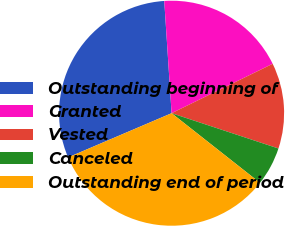Convert chart. <chart><loc_0><loc_0><loc_500><loc_500><pie_chart><fcel>Outstanding beginning of<fcel>Granted<fcel>Vested<fcel>Canceled<fcel>Outstanding end of period<nl><fcel>30.38%<fcel>18.8%<fcel>12.31%<fcel>5.54%<fcel>32.96%<nl></chart> 